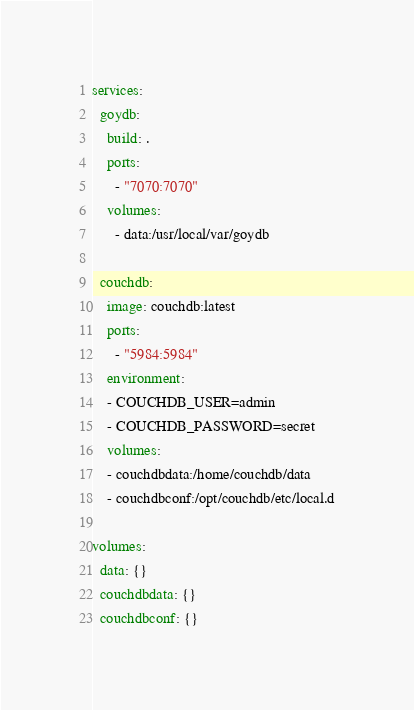Convert code to text. <code><loc_0><loc_0><loc_500><loc_500><_YAML_>services:
  goydb:
    build: .
    ports:
      - "7070:7070"
    volumes:
      - data:/usr/local/var/goydb

  couchdb:
    image: couchdb:latest
    ports:
      - "5984:5984"
    environment:
    - COUCHDB_USER=admin
    - COUCHDB_PASSWORD=secret
    volumes:
    - couchdbdata:/home/couchdb/data
    - couchdbconf:/opt/couchdb/etc/local.d

volumes:
  data: {}
  couchdbdata: {}
  couchdbconf: {}
</code> 